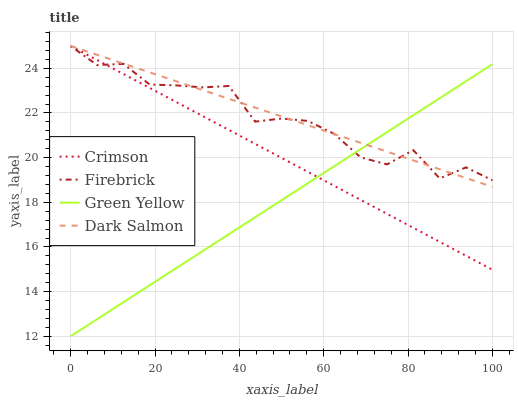Does Green Yellow have the minimum area under the curve?
Answer yes or no. Yes. Does Dark Salmon have the maximum area under the curve?
Answer yes or no. Yes. Does Firebrick have the minimum area under the curve?
Answer yes or no. No. Does Firebrick have the maximum area under the curve?
Answer yes or no. No. Is Dark Salmon the smoothest?
Answer yes or no. Yes. Is Firebrick the roughest?
Answer yes or no. Yes. Is Green Yellow the smoothest?
Answer yes or no. No. Is Green Yellow the roughest?
Answer yes or no. No. Does Green Yellow have the lowest value?
Answer yes or no. Yes. Does Firebrick have the lowest value?
Answer yes or no. No. Does Dark Salmon have the highest value?
Answer yes or no. Yes. Does Green Yellow have the highest value?
Answer yes or no. No. Does Dark Salmon intersect Firebrick?
Answer yes or no. Yes. Is Dark Salmon less than Firebrick?
Answer yes or no. No. Is Dark Salmon greater than Firebrick?
Answer yes or no. No. 